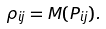Convert formula to latex. <formula><loc_0><loc_0><loc_500><loc_500>\rho _ { i j } = M ( P _ { i j } ) .</formula> 